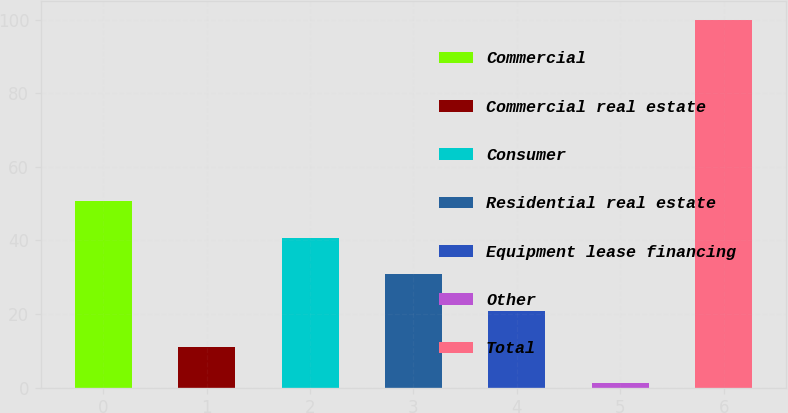Convert chart to OTSL. <chart><loc_0><loc_0><loc_500><loc_500><bar_chart><fcel>Commercial<fcel>Commercial real estate<fcel>Consumer<fcel>Residential real estate<fcel>Equipment lease financing<fcel>Other<fcel>Total<nl><fcel>50.6<fcel>11.08<fcel>40.72<fcel>30.84<fcel>20.96<fcel>1.2<fcel>100<nl></chart> 